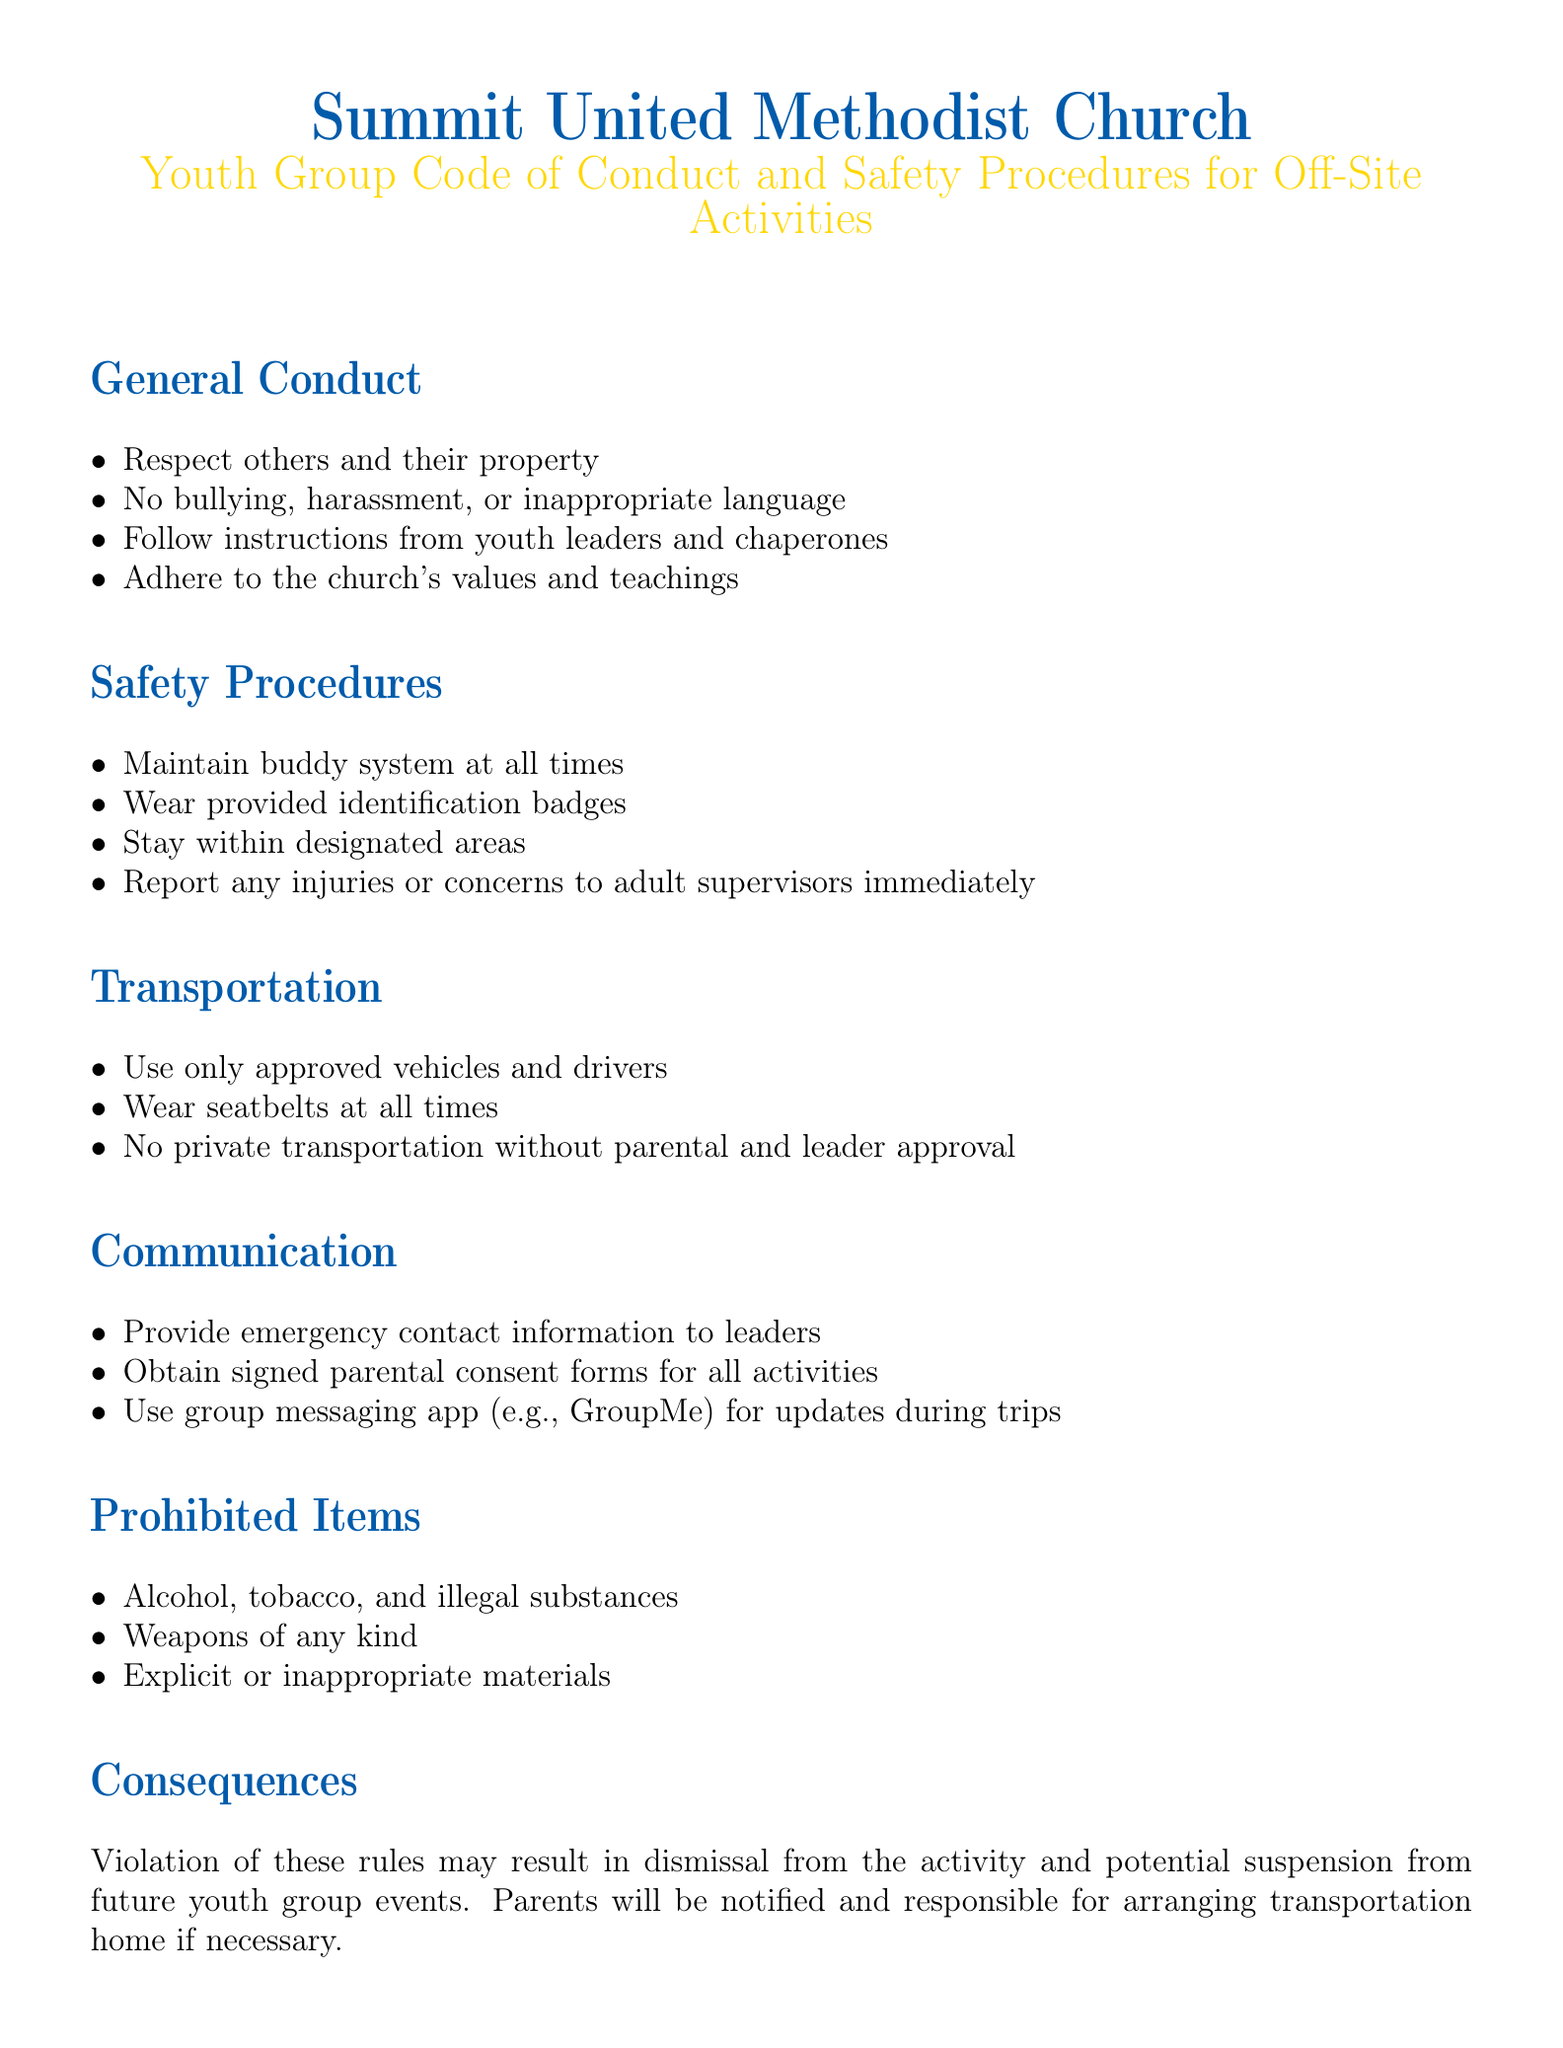What is the title of the document? The title of the document is the main heading at the top, outlining the content it covers.
Answer: Youth Group Code of Conduct and Safety Procedures for Off-Site Activities Who is the Youth Pastor? The Youth Pastor is mentioned in the approval section, indicating leadership within the organization.
Answer: Rev. Michael Thompson What must be worn at all times for safety? The safety section lists a requirement for identifying participants during activities.
Answer: Identification badges What type of communication app is mentioned? The communication section specifies the use of a particular platform for updates, showing the preferred method of communication.
Answer: GroupMe What is prohibited in the activities? The prohibited items section lists several things that cannot be brought, showing the standards expected of participants.
Answer: Alcohol, tobacco, and illegal substances What is the consequence for violation of the code? The consequences section states the potential outcomes for not adhering to the rules, clarifying accountability.
Answer: Dismissal from the activity How should transportation be handled? The transportation section outlines requirements for safe travel, indicating the process that must be followed for all trips.
Answer: Use only approved vehicles and drivers What must leaders be provided with before activities? The communication section outlines what information needs to be shared with leaders to ensure safety and emergency preparedness.
Answer: Emergency contact information 